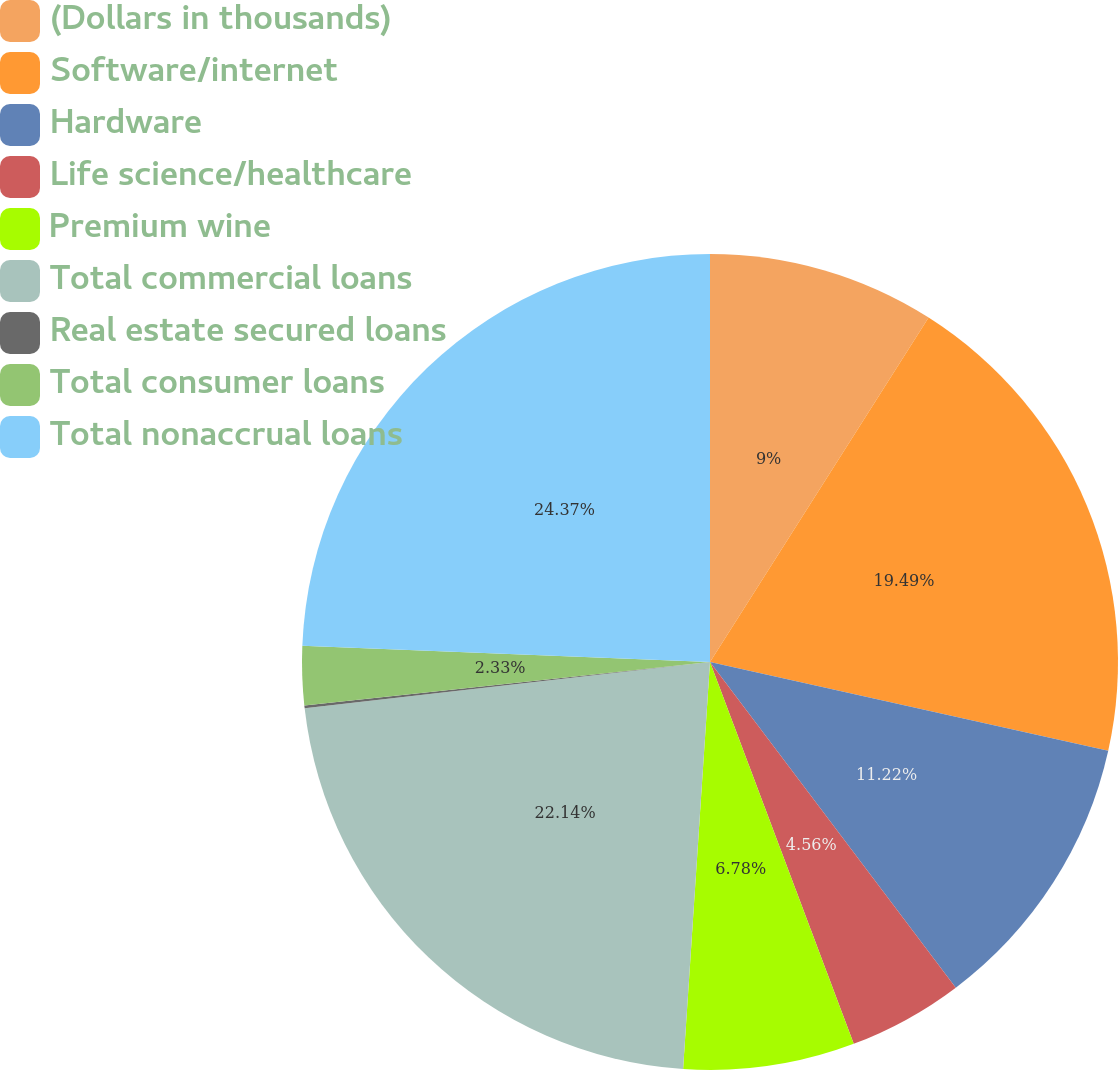<chart> <loc_0><loc_0><loc_500><loc_500><pie_chart><fcel>(Dollars in thousands)<fcel>Software/internet<fcel>Hardware<fcel>Life science/healthcare<fcel>Premium wine<fcel>Total commercial loans<fcel>Real estate secured loans<fcel>Total consumer loans<fcel>Total nonaccrual loans<nl><fcel>9.0%<fcel>19.49%<fcel>11.22%<fcel>4.56%<fcel>6.78%<fcel>22.14%<fcel>0.11%<fcel>2.33%<fcel>24.37%<nl></chart> 